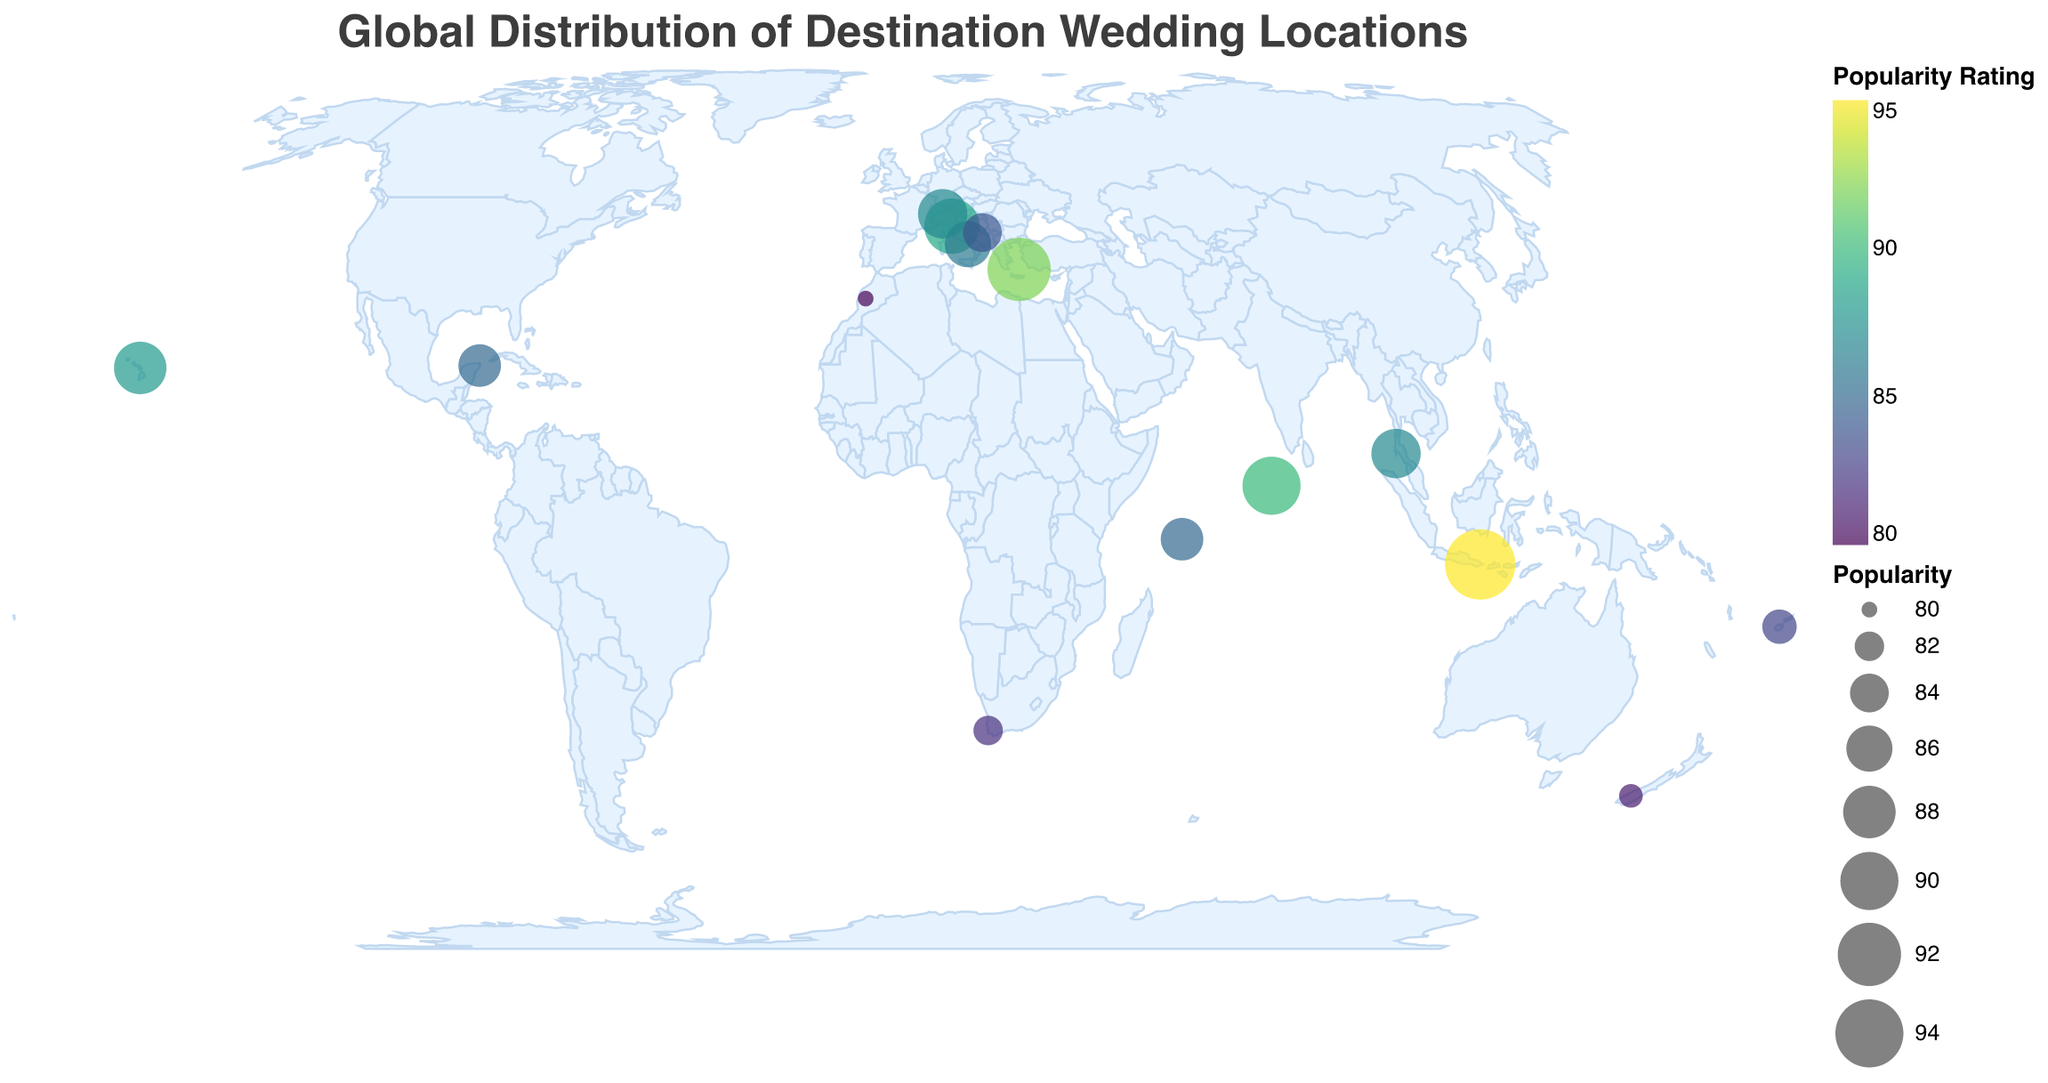What is the most popular destination wedding location? The most popular destination wedding location based on the figure is represented by the largest circle. By checking the sizes of the circles and the corresponding popularity ratings, Bali, Indonesia stands out with a popularity rating of 95.
Answer: Bali, Indonesia Which destination has a lower popularity rating: Santorini, Greece or Marrakech, Morocco? To answer, compare the popularity ratings of both locations. Santorini, Greece has a popularity rating of 92, while Marrakech, Morocco has a popularity rating of 80. Therefore, Santorini, Greece has a higher rating than Marrakech, Morocco.
Answer: Marrakech, Morocco Which continent has the highest number of popular wedding destinations? Examine the map and count the number of circles on each continent. Europe has the most circles (Santorini, Tuscany, Amalfi Coast, Dubrovnik, Lake Como), indicating it has the highest number of popular wedding destinations.
Answer: Europe How does the popularity of Maldives compare to Queenstown, New Zealand? Look at the popularity ratings of Maldives and Queenstown, New Zealand. Maldives has a rating of 90, and Queenstown has a rating of 81. Therefore, Maldives is more popular than Queenstown, New Zealand.
Answer: Maldives is more popular Which location has the smallest circle size on the map, indicating the lowest popularity rating? Compare the circle sizes on the map to find the smallest one. The smallest circle corresponds to Marrakech, Morocco, with a popularity rating of 80.
Answer: Marrakech, Morocco Calculate the average popularity rating of the wedding destinations in Italy. Identify the popularity ratings of all Italian destinations: Tuscany (89), Amalfi Coast (86), and Lake Como (87). Add these ratings and divide by the number of destinations: (89 + 86 + 87) / 3 = 262 / 3 ≈ 87.33.
Answer: 87.33 Which wedding destination is closest to the equator? Find the destination with the latitude closest to 0. The destinations are Bali (-8.4095), Phuket (7.9519), Mauritius (-4.6796), and Maldives (3.2028). Among these, Bali (-8.4095) is closest to the equator.
Answer: Bali, Indonesia Compare the popularity of Maui, Hawaii to Cancun, Mexico. Look at the popularity ratings of both locations. Maui, Hawaii has a rating of 88, while Cancun, Mexico has a rating of 85. Therefore, Maui, Hawaii is more popular than Cancun, Mexico.
Answer: Maui, Hawaii is more popular Estimate the total popularity score for the wedding destinations in the Southern Hemisphere. Identify and sum the popularity ratings of the destinations in the Southern Hemisphere: Bali (95), Fiji (83), Seychelles (85), Cape Town (82), and Queenstown (81). The total popularity score is 95 + 83 + 85 + 82 + 81 = 426.
Answer: 426 